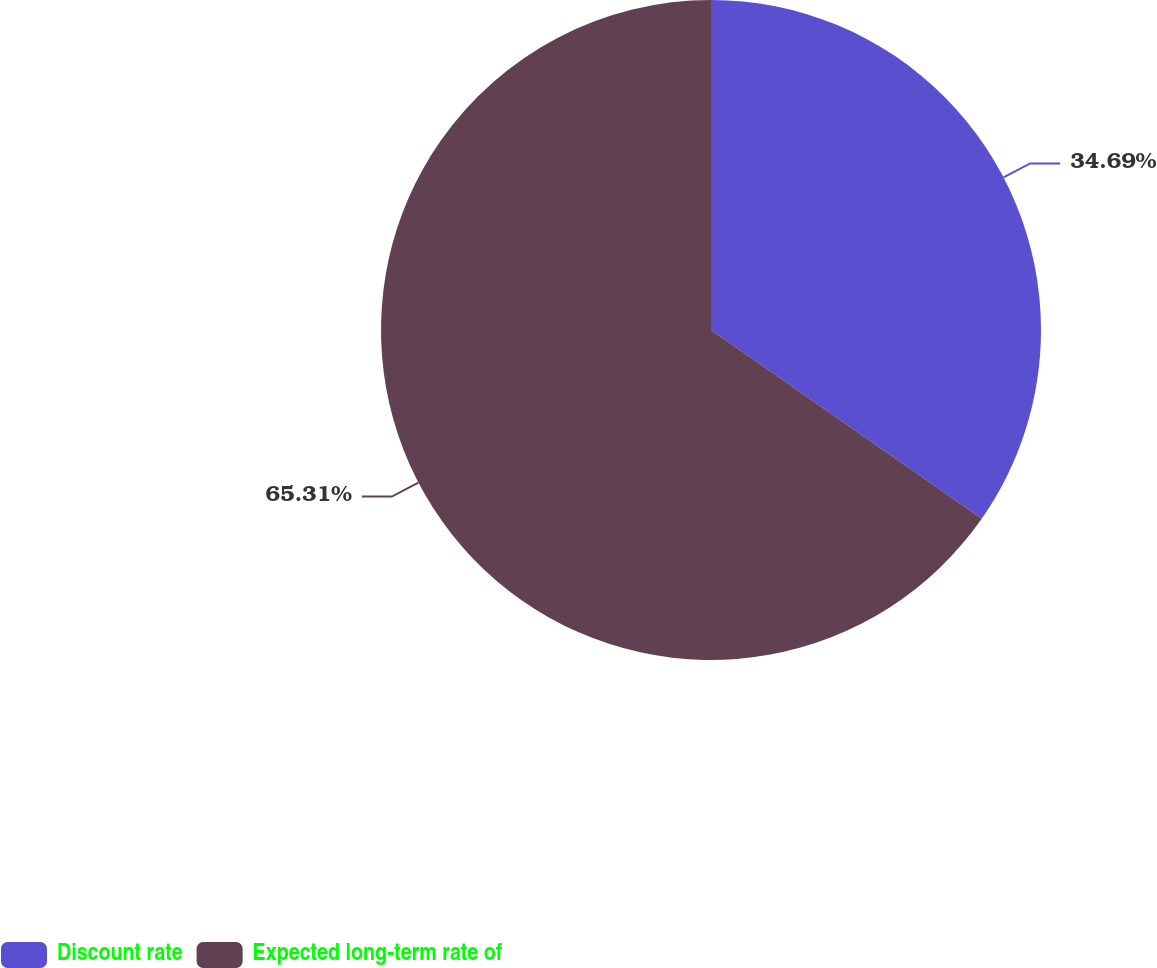Convert chart to OTSL. <chart><loc_0><loc_0><loc_500><loc_500><pie_chart><fcel>Discount rate<fcel>Expected long-term rate of<nl><fcel>34.69%<fcel>65.31%<nl></chart> 